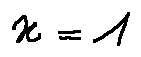Convert formula to latex. <formula><loc_0><loc_0><loc_500><loc_500>x = 1</formula> 